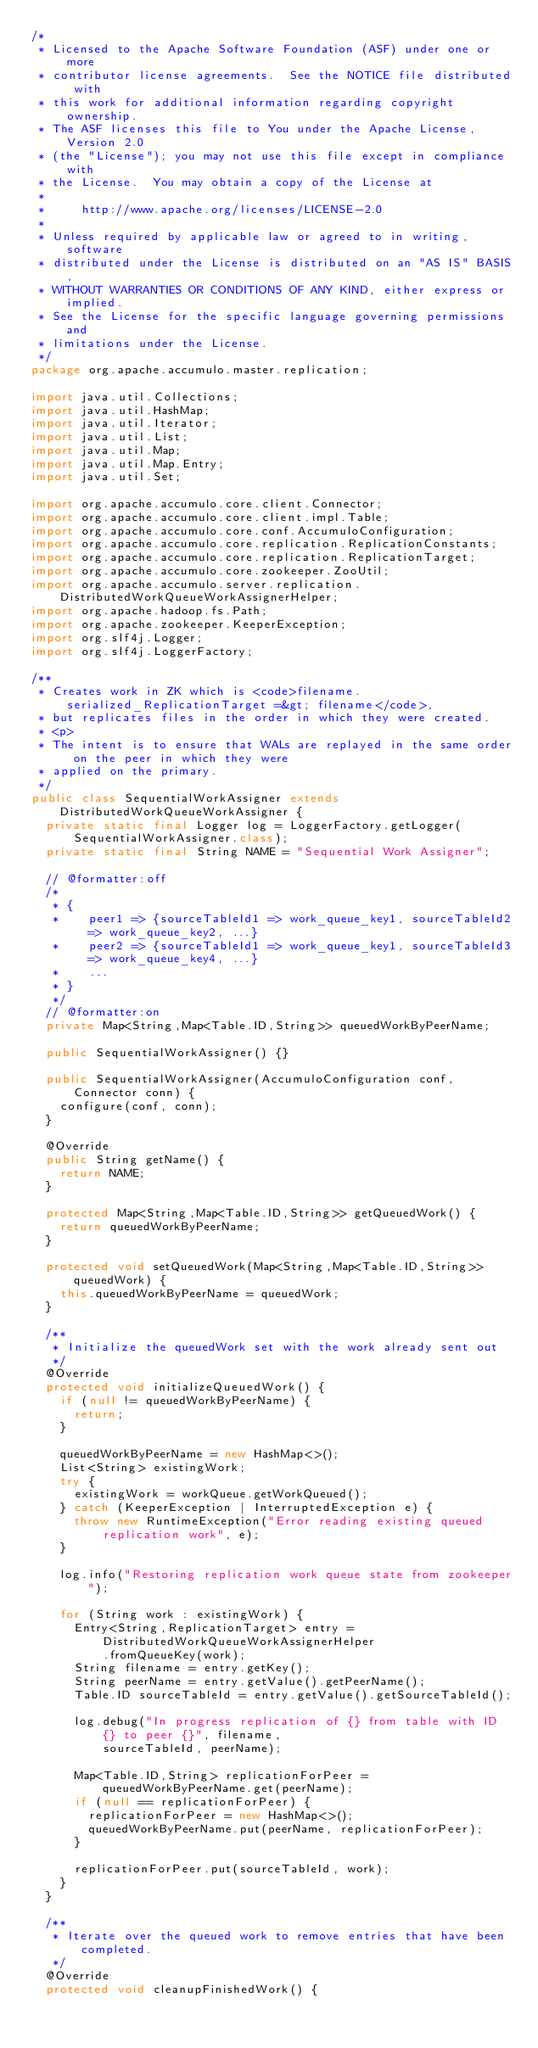<code> <loc_0><loc_0><loc_500><loc_500><_Java_>/*
 * Licensed to the Apache Software Foundation (ASF) under one or more
 * contributor license agreements.  See the NOTICE file distributed with
 * this work for additional information regarding copyright ownership.
 * The ASF licenses this file to You under the Apache License, Version 2.0
 * (the "License"); you may not use this file except in compliance with
 * the License.  You may obtain a copy of the License at
 *
 *     http://www.apache.org/licenses/LICENSE-2.0
 *
 * Unless required by applicable law or agreed to in writing, software
 * distributed under the License is distributed on an "AS IS" BASIS,
 * WITHOUT WARRANTIES OR CONDITIONS OF ANY KIND, either express or implied.
 * See the License for the specific language governing permissions and
 * limitations under the License.
 */
package org.apache.accumulo.master.replication;

import java.util.Collections;
import java.util.HashMap;
import java.util.Iterator;
import java.util.List;
import java.util.Map;
import java.util.Map.Entry;
import java.util.Set;

import org.apache.accumulo.core.client.Connector;
import org.apache.accumulo.core.client.impl.Table;
import org.apache.accumulo.core.conf.AccumuloConfiguration;
import org.apache.accumulo.core.replication.ReplicationConstants;
import org.apache.accumulo.core.replication.ReplicationTarget;
import org.apache.accumulo.core.zookeeper.ZooUtil;
import org.apache.accumulo.server.replication.DistributedWorkQueueWorkAssignerHelper;
import org.apache.hadoop.fs.Path;
import org.apache.zookeeper.KeeperException;
import org.slf4j.Logger;
import org.slf4j.LoggerFactory;

/**
 * Creates work in ZK which is <code>filename.serialized_ReplicationTarget =&gt; filename</code>,
 * but replicates files in the order in which they were created.
 * <p>
 * The intent is to ensure that WALs are replayed in the same order on the peer in which they were
 * applied on the primary.
 */
public class SequentialWorkAssigner extends DistributedWorkQueueWorkAssigner {
  private static final Logger log = LoggerFactory.getLogger(SequentialWorkAssigner.class);
  private static final String NAME = "Sequential Work Assigner";

  // @formatter:off
  /*
   * {
   *    peer1 => {sourceTableId1 => work_queue_key1, sourceTableId2 => work_queue_key2, ...}
   *    peer2 => {sourceTableId1 => work_queue_key1, sourceTableId3 => work_queue_key4, ...}
   *    ...
   * }
   */
  // @formatter:on
  private Map<String,Map<Table.ID,String>> queuedWorkByPeerName;

  public SequentialWorkAssigner() {}

  public SequentialWorkAssigner(AccumuloConfiguration conf, Connector conn) {
    configure(conf, conn);
  }

  @Override
  public String getName() {
    return NAME;
  }

  protected Map<String,Map<Table.ID,String>> getQueuedWork() {
    return queuedWorkByPeerName;
  }

  protected void setQueuedWork(Map<String,Map<Table.ID,String>> queuedWork) {
    this.queuedWorkByPeerName = queuedWork;
  }

  /**
   * Initialize the queuedWork set with the work already sent out
   */
  @Override
  protected void initializeQueuedWork() {
    if (null != queuedWorkByPeerName) {
      return;
    }

    queuedWorkByPeerName = new HashMap<>();
    List<String> existingWork;
    try {
      existingWork = workQueue.getWorkQueued();
    } catch (KeeperException | InterruptedException e) {
      throw new RuntimeException("Error reading existing queued replication work", e);
    }

    log.info("Restoring replication work queue state from zookeeper");

    for (String work : existingWork) {
      Entry<String,ReplicationTarget> entry = DistributedWorkQueueWorkAssignerHelper
          .fromQueueKey(work);
      String filename = entry.getKey();
      String peerName = entry.getValue().getPeerName();
      Table.ID sourceTableId = entry.getValue().getSourceTableId();

      log.debug("In progress replication of {} from table with ID {} to peer {}", filename,
          sourceTableId, peerName);

      Map<Table.ID,String> replicationForPeer = queuedWorkByPeerName.get(peerName);
      if (null == replicationForPeer) {
        replicationForPeer = new HashMap<>();
        queuedWorkByPeerName.put(peerName, replicationForPeer);
      }

      replicationForPeer.put(sourceTableId, work);
    }
  }

  /**
   * Iterate over the queued work to remove entries that have been completed.
   */
  @Override
  protected void cleanupFinishedWork() {</code> 